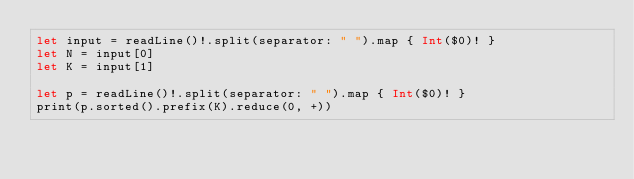<code> <loc_0><loc_0><loc_500><loc_500><_Swift_>let input = readLine()!.split(separator: " ").map { Int($0)! }
let N = input[0]
let K = input[1]

let p = readLine()!.split(separator: " ").map { Int($0)! }
print(p.sorted().prefix(K).reduce(0, +))</code> 